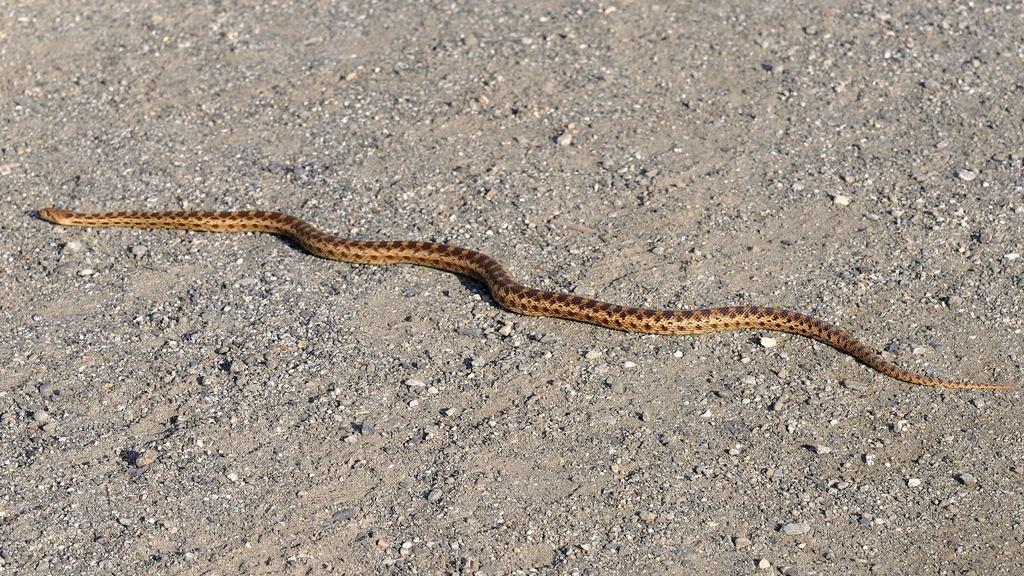In one or two sentences, can you explain what this image depicts? In this image I can see the snake and the snake is in brown and cream color and I can also see few stones. 